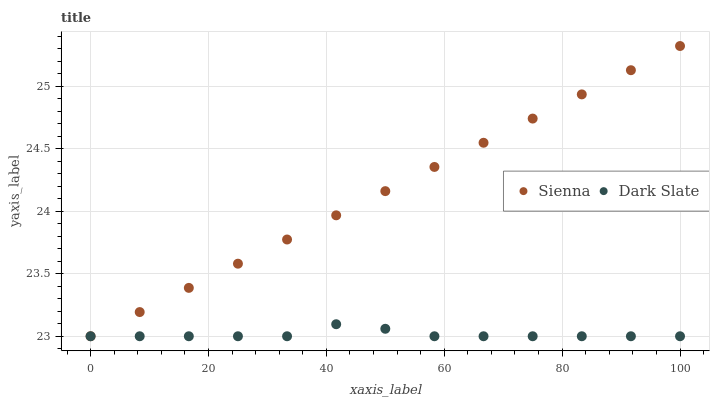Does Dark Slate have the minimum area under the curve?
Answer yes or no. Yes. Does Sienna have the maximum area under the curve?
Answer yes or no. Yes. Does Dark Slate have the maximum area under the curve?
Answer yes or no. No. Is Sienna the smoothest?
Answer yes or no. Yes. Is Dark Slate the roughest?
Answer yes or no. Yes. Is Dark Slate the smoothest?
Answer yes or no. No. Does Sienna have the lowest value?
Answer yes or no. Yes. Does Sienna have the highest value?
Answer yes or no. Yes. Does Dark Slate have the highest value?
Answer yes or no. No. Does Sienna intersect Dark Slate?
Answer yes or no. Yes. Is Sienna less than Dark Slate?
Answer yes or no. No. Is Sienna greater than Dark Slate?
Answer yes or no. No. 